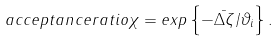Convert formula to latex. <formula><loc_0><loc_0><loc_500><loc_500>a c c e p t a n c e r a t i o \chi = e x p \left \{ - \bar { \Delta \zeta } / \vartheta _ { i } \right \} .</formula> 